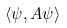<formula> <loc_0><loc_0><loc_500><loc_500>\langle \psi , A \psi \rangle</formula> 